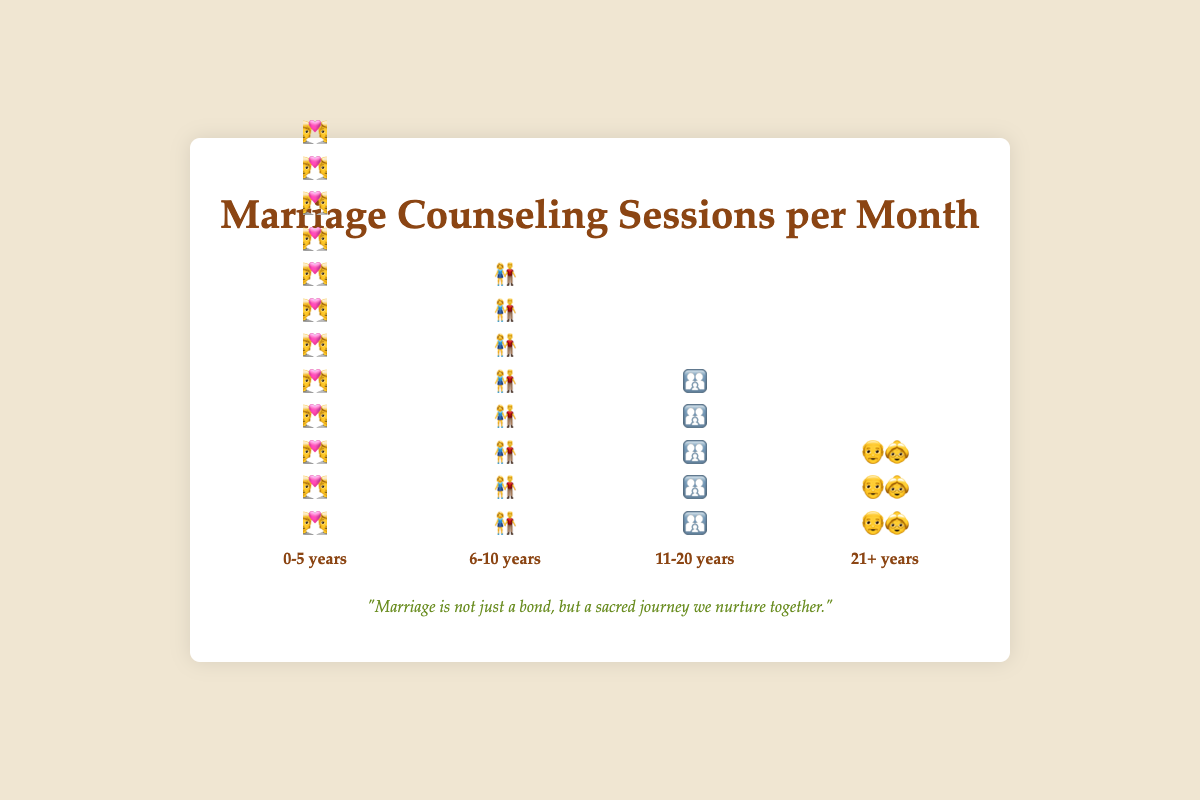Which category of years of marriage has the highest frequency of counseling sessions per month? The category "0-5 years" has the highest frequency, as indicated by the longest column of heart icons (💑), totaling 12 sessions per month.
Answer: 0-5 years How many total sessions are conducted per month for marriages lasting between 0-10 years? Add the sessions from the "0-5 years" category (12 sessions) and the "6-10 years" category (8 sessions). Therefore, total sessions are 12 + 8 = 20.
Answer: 20 What is the difference in the number of counseling sessions per month between the "0-5 years" and "21+ years" categories? Subtract the number of sessions for "21+ years" (3 sessions) from the number of sessions for "0-5 years" (12 sessions). Thus, the difference is 12 - 3 = 9.
Answer: 9 Which category has fewer counseling sessions per month: "11-20 years" or "6-10 years"? The "11-20 years" category has 5 sessions per month, while "6-10 years" has 8 sessions per month. Since 5 < 8, "11-20 years" has fewer.
Answer: 11-20 years How does the frequency of counseling sessions change as the years of marriage increase? As the years of marriage increase, the frequency of marriage counseling sessions decreases, evident from the decreasing height of the columns and fewer icons (from 12 sessions in "0-5 years" to 3 sessions in "21+ years").
Answer: Decreases Compare the total number of sessions per month for couples married 11 years or more (both "11-20 years" and "21+ years") to those married for 10 years or fewer ("0-5 years" and "6-10 years"). Add the sessions: "11-20 years" (5) + "21+ years" (3) = 8 sessions; then "0-5 years" (12) + "6-10 years" (8) = 20 sessions. Couples married for 10 years or fewer have 20 sessions, which is more than the 8 sessions for those married 11 years or more.
Answer: 10 years or fewer Which category represents the middle frequency range for marriage counseling sessions? The "6-10 years" category, with its 8 sessions per month, falls between the higher frequency of "0-5 years" (12 sessions) and the lower frequencies of "11-20 years" (5 sessions) and "21+ years" (3 sessions).
Answer: 6-10 years 